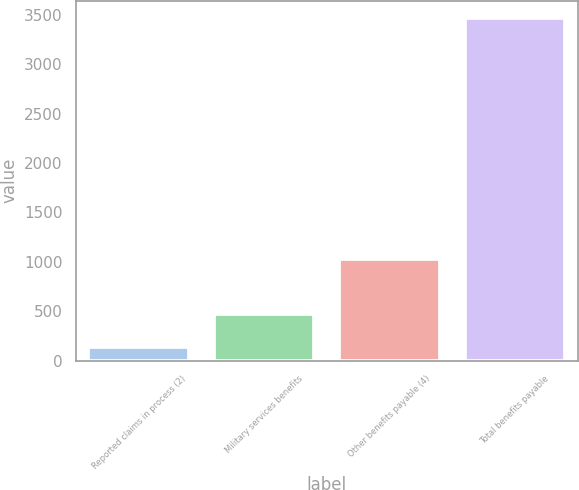Convert chart to OTSL. <chart><loc_0><loc_0><loc_500><loc_500><bar_chart><fcel>Reported claims in process (2)<fcel>Military services benefits<fcel>Other benefits payable (4)<fcel>Total benefits payable<nl><fcel>137<fcel>470.2<fcel>1026<fcel>3469<nl></chart> 